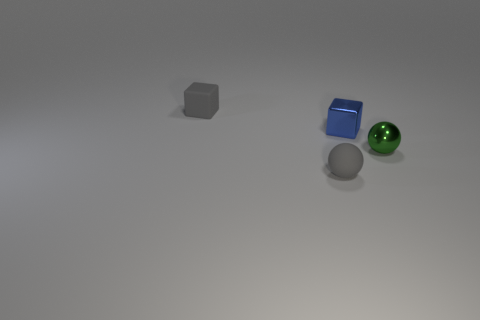Are there any other things that are the same size as the green ball?
Your answer should be compact. Yes. The rubber sphere has what size?
Your response must be concise. Small. What number of big objects are either matte cubes or brown spheres?
Provide a succinct answer. 0. Is the size of the green shiny thing the same as the matte thing that is in front of the tiny blue metallic cube?
Offer a very short reply. Yes. Is there anything else that has the same shape as the tiny blue object?
Make the answer very short. Yes. How many big gray cylinders are there?
Offer a very short reply. 0. How many gray things are matte spheres or tiny metal blocks?
Provide a short and direct response. 1. Does the sphere that is in front of the tiny green metallic thing have the same material as the green object?
Make the answer very short. No. What number of other objects are there of the same material as the tiny blue cube?
Keep it short and to the point. 1. What is the material of the tiny green thing?
Keep it short and to the point. Metal. 